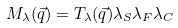Convert formula to latex. <formula><loc_0><loc_0><loc_500><loc_500>M _ { \lambda } ( \vec { q } ) = T _ { \lambda } ( \vec { q } ) \lambda _ { S } \lambda _ { F } \lambda _ { C }</formula> 